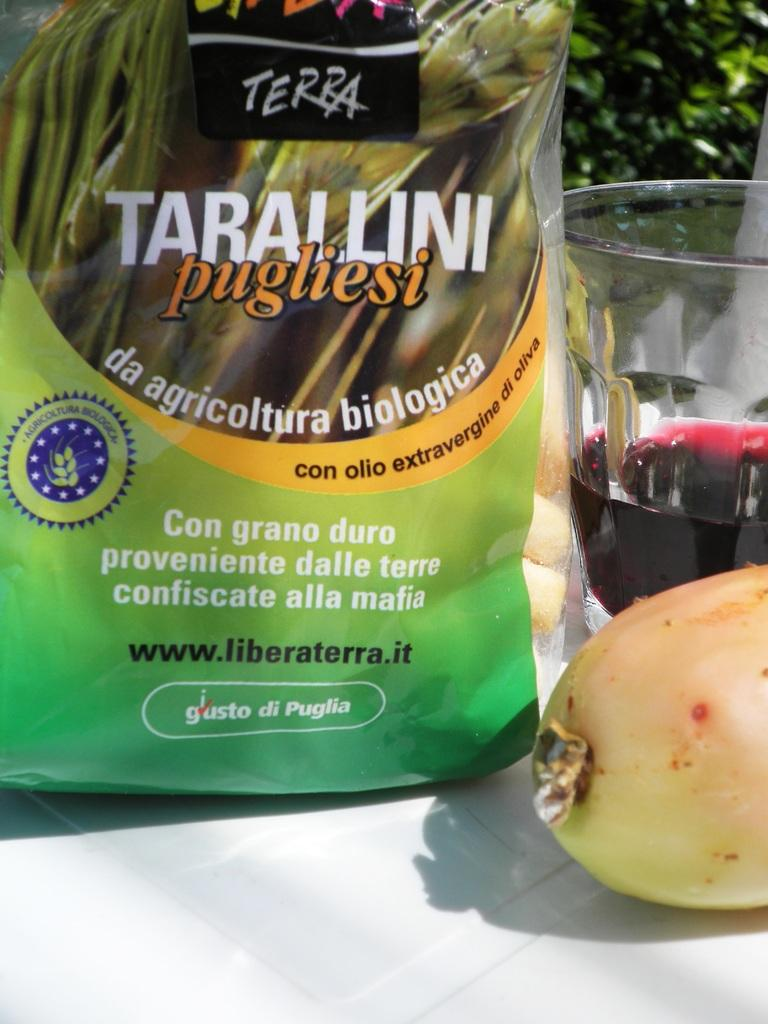<image>
Write a terse but informative summary of the picture. A glass of wine and a bag of Tarallini pugliesi. 